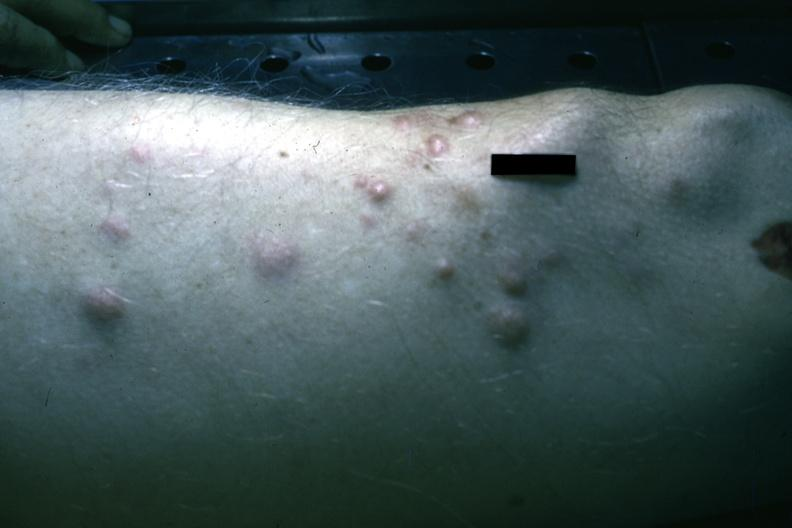what is present?
Answer the question using a single word or phrase. Multiple myeloma 